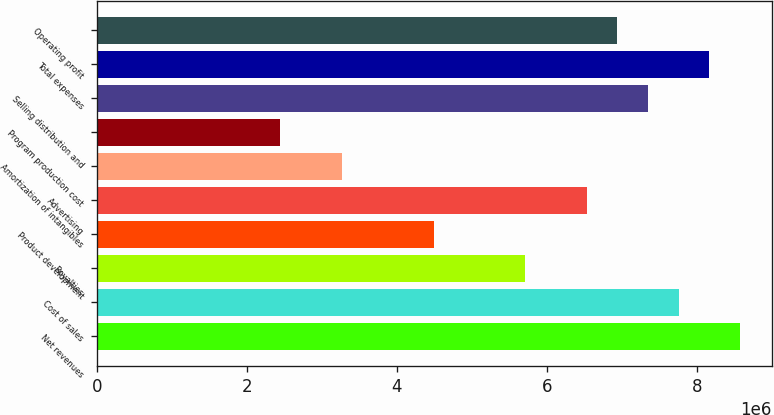Convert chart. <chart><loc_0><loc_0><loc_500><loc_500><bar_chart><fcel>Net revenues<fcel>Cost of sales<fcel>Royalties<fcel>Product development<fcel>Advertising<fcel>Amortization of intangibles<fcel>Program production cost<fcel>Selling distribution and<fcel>Total expenses<fcel>Operating profit<nl><fcel>8.57253e+06<fcel>7.7561e+06<fcel>5.71502e+06<fcel>4.49037e+06<fcel>6.53145e+06<fcel>3.26573e+06<fcel>2.44929e+06<fcel>7.34788e+06<fcel>8.16431e+06<fcel>6.93967e+06<nl></chart> 